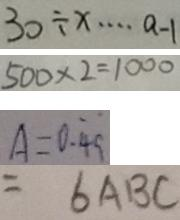Convert formula to latex. <formula><loc_0><loc_0><loc_500><loc_500>3 0 \div x \cdots a - 1 
 5 0 0 \times 2 = 1 0 0 0 
 A = 0 . \dot { 4 } \dot { 9 } 
 = 6 A B C</formula> 